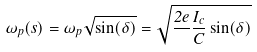Convert formula to latex. <formula><loc_0><loc_0><loc_500><loc_500>\omega _ { p } ( s ) = \omega _ { p } \sqrt { \sin ( \delta ) } = \sqrt { \frac { 2 e } { } \frac { I _ { c } } { C } \sin ( \delta ) }</formula> 